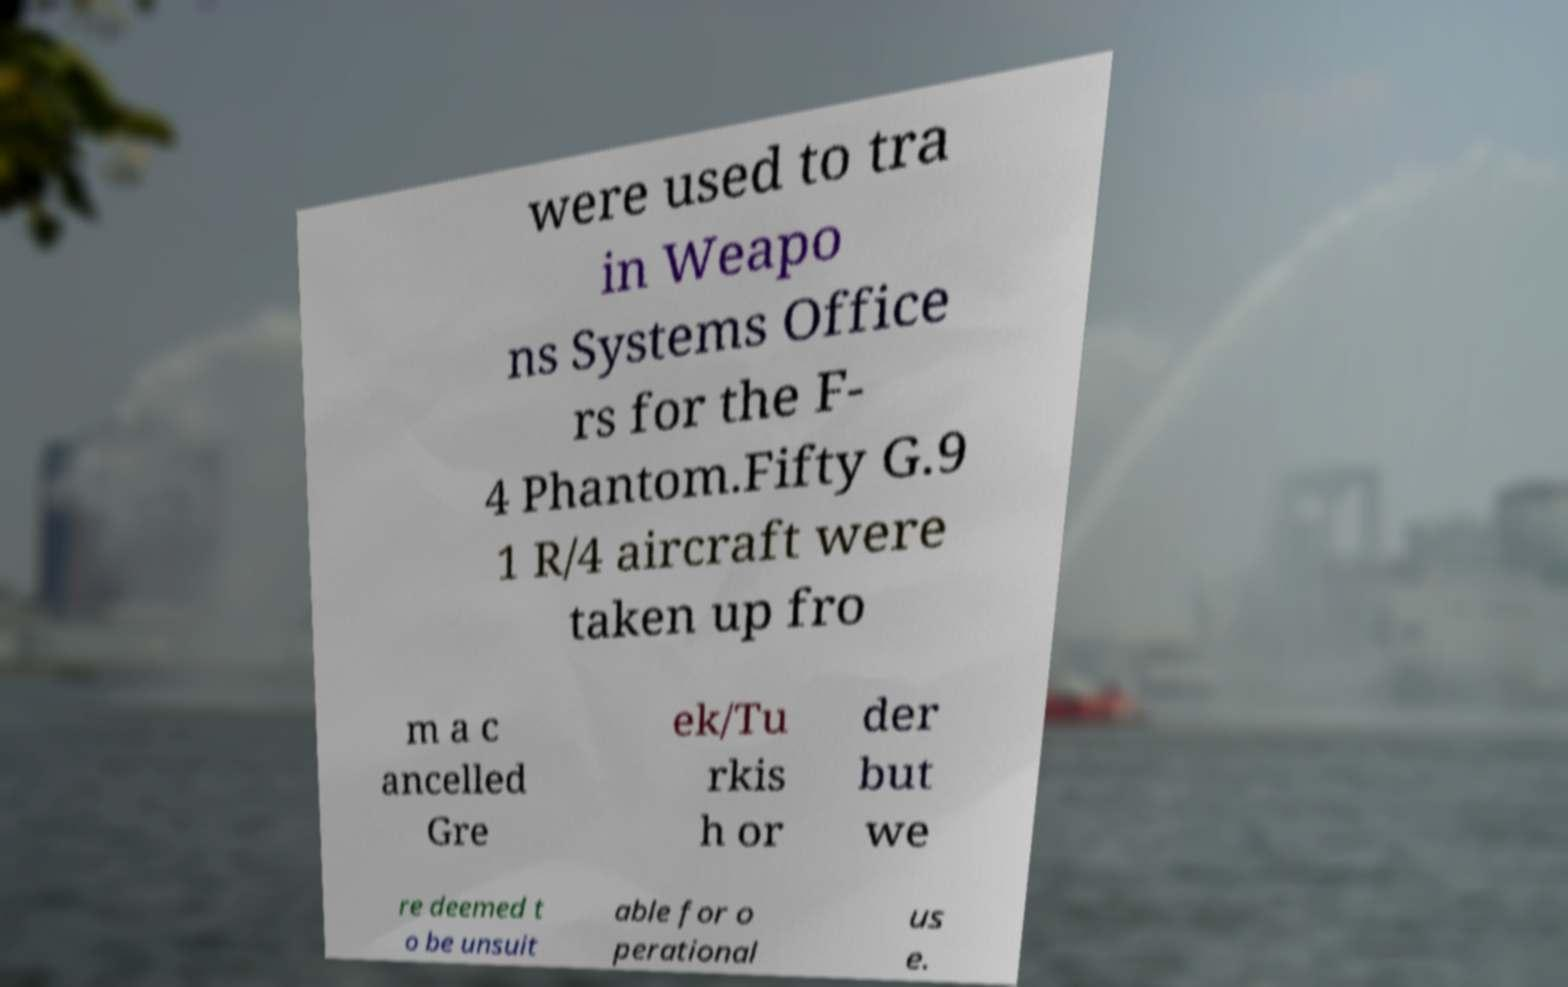I need the written content from this picture converted into text. Can you do that? were used to tra in Weapo ns Systems Office rs for the F- 4 Phantom.Fifty G.9 1 R/4 aircraft were taken up fro m a c ancelled Gre ek/Tu rkis h or der but we re deemed t o be unsuit able for o perational us e. 